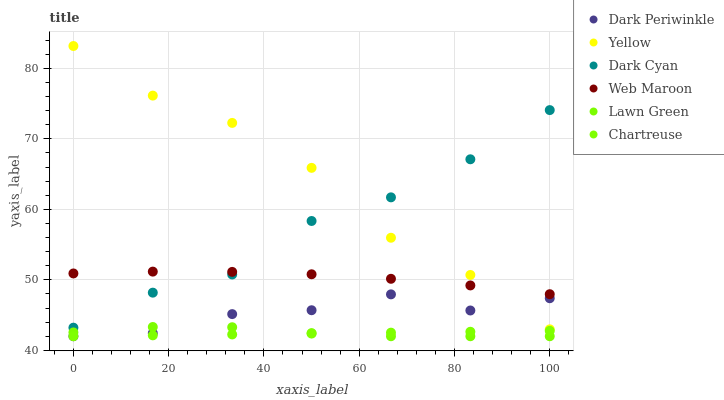Does Chartreuse have the minimum area under the curve?
Answer yes or no. Yes. Does Yellow have the maximum area under the curve?
Answer yes or no. Yes. Does Web Maroon have the minimum area under the curve?
Answer yes or no. No. Does Web Maroon have the maximum area under the curve?
Answer yes or no. No. Is Chartreuse the smoothest?
Answer yes or no. Yes. Is Yellow the roughest?
Answer yes or no. Yes. Is Web Maroon the smoothest?
Answer yes or no. No. Is Web Maroon the roughest?
Answer yes or no. No. Does Lawn Green have the lowest value?
Answer yes or no. Yes. Does Yellow have the lowest value?
Answer yes or no. No. Does Yellow have the highest value?
Answer yes or no. Yes. Does Web Maroon have the highest value?
Answer yes or no. No. Is Lawn Green less than Web Maroon?
Answer yes or no. Yes. Is Dark Cyan greater than Chartreuse?
Answer yes or no. Yes. Does Lawn Green intersect Dark Periwinkle?
Answer yes or no. Yes. Is Lawn Green less than Dark Periwinkle?
Answer yes or no. No. Is Lawn Green greater than Dark Periwinkle?
Answer yes or no. No. Does Lawn Green intersect Web Maroon?
Answer yes or no. No. 